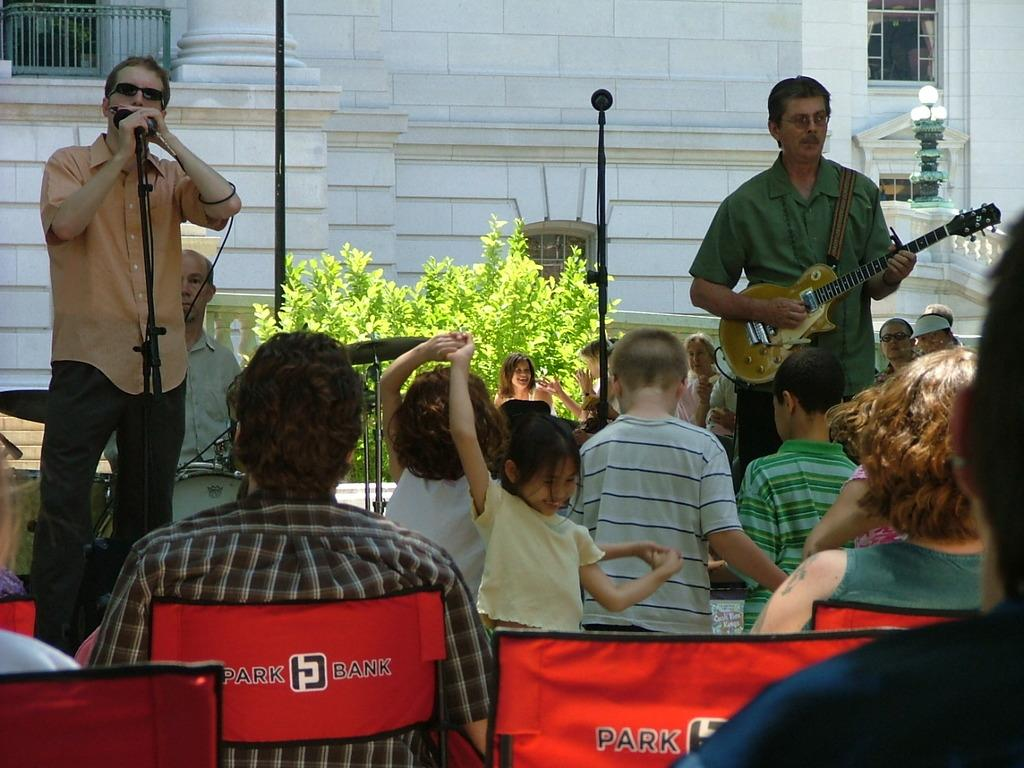How many people are in the image? There are persons in the image. What is one person doing in the image? One person is playing a guitar. What is the person playing the guitar also doing? The person playing the guitar is singing on a microphone. What can be seen in the background of the image? There is a wall in the background of the image. What type of vegetation is present in the image? There is a plant in the image. What type of faucet can be seen in the image? There is no faucet present in the image. How many bears are visible in the image? There are no bears visible in the image. 